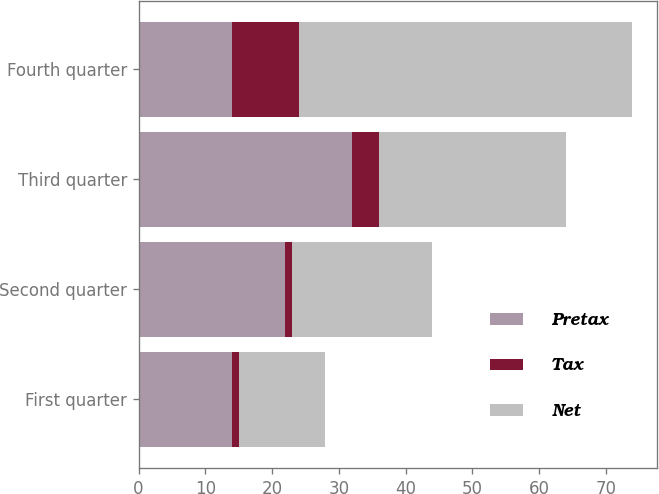Convert chart. <chart><loc_0><loc_0><loc_500><loc_500><stacked_bar_chart><ecel><fcel>First quarter<fcel>Second quarter<fcel>Third quarter<fcel>Fourth quarter<nl><fcel>Pretax<fcel>14<fcel>22<fcel>32<fcel>14<nl><fcel>Tax<fcel>1<fcel>1<fcel>4<fcel>10<nl><fcel>Net<fcel>13<fcel>21<fcel>28<fcel>50<nl></chart> 